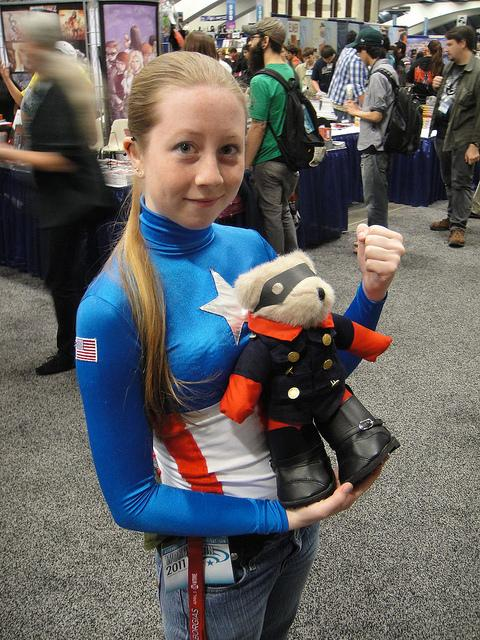In which sort of event does this woman pose?

Choices:
A) sale
B) auction
C) art musem
D) expo expo 